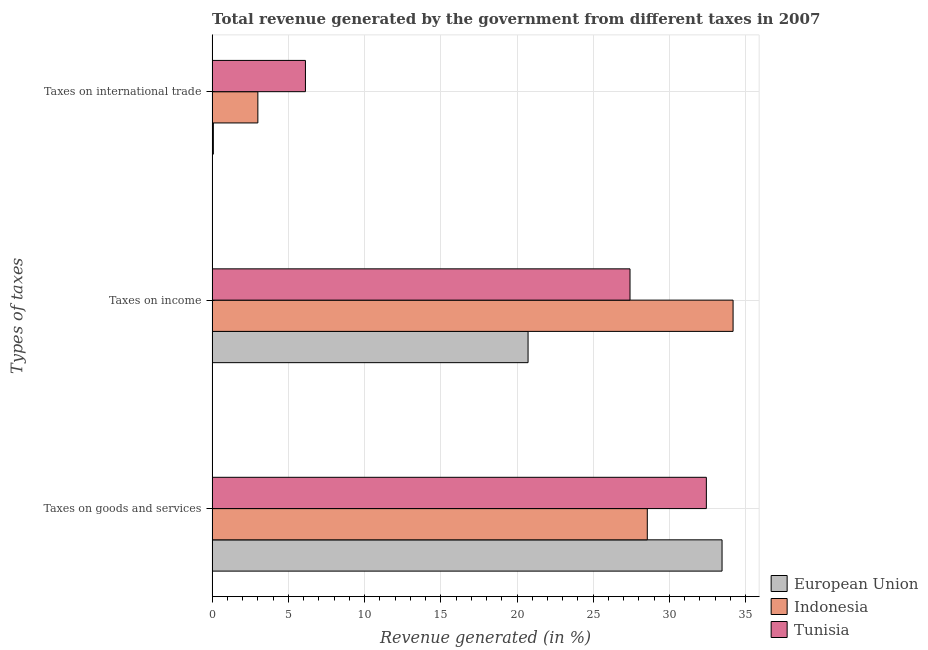How many different coloured bars are there?
Your answer should be very brief. 3. How many groups of bars are there?
Your answer should be very brief. 3. Are the number of bars per tick equal to the number of legend labels?
Give a very brief answer. Yes. How many bars are there on the 2nd tick from the top?
Your answer should be very brief. 3. How many bars are there on the 1st tick from the bottom?
Keep it short and to the point. 3. What is the label of the 2nd group of bars from the top?
Your answer should be very brief. Taxes on income. What is the percentage of revenue generated by taxes on goods and services in Tunisia?
Your response must be concise. 32.42. Across all countries, what is the maximum percentage of revenue generated by tax on international trade?
Keep it short and to the point. 6.12. Across all countries, what is the minimum percentage of revenue generated by taxes on goods and services?
Give a very brief answer. 28.55. In which country was the percentage of revenue generated by taxes on goods and services maximum?
Offer a very short reply. European Union. In which country was the percentage of revenue generated by tax on international trade minimum?
Your answer should be compact. European Union. What is the total percentage of revenue generated by taxes on goods and services in the graph?
Ensure brevity in your answer.  94.42. What is the difference between the percentage of revenue generated by taxes on income in European Union and that in Tunisia?
Your response must be concise. -6.69. What is the difference between the percentage of revenue generated by tax on international trade in European Union and the percentage of revenue generated by taxes on income in Indonesia?
Your response must be concise. -34.09. What is the average percentage of revenue generated by taxes on income per country?
Make the answer very short. 27.44. What is the difference between the percentage of revenue generated by taxes on income and percentage of revenue generated by tax on international trade in Tunisia?
Offer a terse response. 21.29. In how many countries, is the percentage of revenue generated by taxes on goods and services greater than 22 %?
Your response must be concise. 3. What is the ratio of the percentage of revenue generated by tax on international trade in Tunisia to that in European Union?
Provide a short and direct response. 75.89. What is the difference between the highest and the second highest percentage of revenue generated by tax on international trade?
Provide a short and direct response. 3.12. What is the difference between the highest and the lowest percentage of revenue generated by taxes on income?
Ensure brevity in your answer.  13.45. In how many countries, is the percentage of revenue generated by taxes on income greater than the average percentage of revenue generated by taxes on income taken over all countries?
Ensure brevity in your answer.  1. What does the 1st bar from the top in Taxes on international trade represents?
Give a very brief answer. Tunisia. Is it the case that in every country, the sum of the percentage of revenue generated by taxes on goods and services and percentage of revenue generated by taxes on income is greater than the percentage of revenue generated by tax on international trade?
Give a very brief answer. Yes. How many bars are there?
Your answer should be compact. 9. Are all the bars in the graph horizontal?
Ensure brevity in your answer.  Yes. How many countries are there in the graph?
Your response must be concise. 3. Are the values on the major ticks of X-axis written in scientific E-notation?
Keep it short and to the point. No. Does the graph contain any zero values?
Provide a succinct answer. No. Does the graph contain grids?
Give a very brief answer. Yes. Where does the legend appear in the graph?
Offer a very short reply. Bottom right. How many legend labels are there?
Your answer should be compact. 3. How are the legend labels stacked?
Your answer should be compact. Vertical. What is the title of the graph?
Your answer should be compact. Total revenue generated by the government from different taxes in 2007. Does "Barbados" appear as one of the legend labels in the graph?
Your answer should be compact. No. What is the label or title of the X-axis?
Your answer should be compact. Revenue generated (in %). What is the label or title of the Y-axis?
Ensure brevity in your answer.  Types of taxes. What is the Revenue generated (in %) of European Union in Taxes on goods and services?
Offer a terse response. 33.45. What is the Revenue generated (in %) of Indonesia in Taxes on goods and services?
Provide a succinct answer. 28.55. What is the Revenue generated (in %) of Tunisia in Taxes on goods and services?
Offer a terse response. 32.42. What is the Revenue generated (in %) of European Union in Taxes on income?
Offer a very short reply. 20.72. What is the Revenue generated (in %) in Indonesia in Taxes on income?
Provide a short and direct response. 34.17. What is the Revenue generated (in %) of Tunisia in Taxes on income?
Keep it short and to the point. 27.41. What is the Revenue generated (in %) in European Union in Taxes on international trade?
Offer a very short reply. 0.08. What is the Revenue generated (in %) in Indonesia in Taxes on international trade?
Provide a short and direct response. 3. What is the Revenue generated (in %) of Tunisia in Taxes on international trade?
Your response must be concise. 6.12. Across all Types of taxes, what is the maximum Revenue generated (in %) of European Union?
Give a very brief answer. 33.45. Across all Types of taxes, what is the maximum Revenue generated (in %) of Indonesia?
Your answer should be compact. 34.17. Across all Types of taxes, what is the maximum Revenue generated (in %) in Tunisia?
Provide a succinct answer. 32.42. Across all Types of taxes, what is the minimum Revenue generated (in %) of European Union?
Offer a very short reply. 0.08. Across all Types of taxes, what is the minimum Revenue generated (in %) in Indonesia?
Your response must be concise. 3. Across all Types of taxes, what is the minimum Revenue generated (in %) of Tunisia?
Your answer should be compact. 6.12. What is the total Revenue generated (in %) in European Union in the graph?
Your answer should be very brief. 54.26. What is the total Revenue generated (in %) of Indonesia in the graph?
Your answer should be compact. 65.72. What is the total Revenue generated (in %) of Tunisia in the graph?
Provide a short and direct response. 65.96. What is the difference between the Revenue generated (in %) in European Union in Taxes on goods and services and that in Taxes on income?
Provide a short and direct response. 12.73. What is the difference between the Revenue generated (in %) in Indonesia in Taxes on goods and services and that in Taxes on income?
Give a very brief answer. -5.63. What is the difference between the Revenue generated (in %) in Tunisia in Taxes on goods and services and that in Taxes on income?
Make the answer very short. 5.01. What is the difference between the Revenue generated (in %) of European Union in Taxes on goods and services and that in Taxes on international trade?
Offer a very short reply. 33.37. What is the difference between the Revenue generated (in %) in Indonesia in Taxes on goods and services and that in Taxes on international trade?
Your answer should be very brief. 25.55. What is the difference between the Revenue generated (in %) in Tunisia in Taxes on goods and services and that in Taxes on international trade?
Offer a terse response. 26.3. What is the difference between the Revenue generated (in %) of European Union in Taxes on income and that in Taxes on international trade?
Your answer should be very brief. 20.64. What is the difference between the Revenue generated (in %) of Indonesia in Taxes on income and that in Taxes on international trade?
Offer a very short reply. 31.17. What is the difference between the Revenue generated (in %) in Tunisia in Taxes on income and that in Taxes on international trade?
Ensure brevity in your answer.  21.29. What is the difference between the Revenue generated (in %) in European Union in Taxes on goods and services and the Revenue generated (in %) in Indonesia in Taxes on income?
Your response must be concise. -0.72. What is the difference between the Revenue generated (in %) of European Union in Taxes on goods and services and the Revenue generated (in %) of Tunisia in Taxes on income?
Make the answer very short. 6.04. What is the difference between the Revenue generated (in %) in Indonesia in Taxes on goods and services and the Revenue generated (in %) in Tunisia in Taxes on income?
Ensure brevity in your answer.  1.13. What is the difference between the Revenue generated (in %) of European Union in Taxes on goods and services and the Revenue generated (in %) of Indonesia in Taxes on international trade?
Offer a terse response. 30.45. What is the difference between the Revenue generated (in %) in European Union in Taxes on goods and services and the Revenue generated (in %) in Tunisia in Taxes on international trade?
Give a very brief answer. 27.33. What is the difference between the Revenue generated (in %) of Indonesia in Taxes on goods and services and the Revenue generated (in %) of Tunisia in Taxes on international trade?
Make the answer very short. 22.43. What is the difference between the Revenue generated (in %) in European Union in Taxes on income and the Revenue generated (in %) in Indonesia in Taxes on international trade?
Ensure brevity in your answer.  17.73. What is the difference between the Revenue generated (in %) of European Union in Taxes on income and the Revenue generated (in %) of Tunisia in Taxes on international trade?
Make the answer very short. 14.6. What is the difference between the Revenue generated (in %) of Indonesia in Taxes on income and the Revenue generated (in %) of Tunisia in Taxes on international trade?
Make the answer very short. 28.05. What is the average Revenue generated (in %) in European Union per Types of taxes?
Keep it short and to the point. 18.09. What is the average Revenue generated (in %) of Indonesia per Types of taxes?
Ensure brevity in your answer.  21.91. What is the average Revenue generated (in %) in Tunisia per Types of taxes?
Ensure brevity in your answer.  21.99. What is the difference between the Revenue generated (in %) of European Union and Revenue generated (in %) of Indonesia in Taxes on goods and services?
Give a very brief answer. 4.9. What is the difference between the Revenue generated (in %) in European Union and Revenue generated (in %) in Tunisia in Taxes on goods and services?
Make the answer very short. 1.03. What is the difference between the Revenue generated (in %) of Indonesia and Revenue generated (in %) of Tunisia in Taxes on goods and services?
Your response must be concise. -3.87. What is the difference between the Revenue generated (in %) of European Union and Revenue generated (in %) of Indonesia in Taxes on income?
Keep it short and to the point. -13.45. What is the difference between the Revenue generated (in %) of European Union and Revenue generated (in %) of Tunisia in Taxes on income?
Your response must be concise. -6.69. What is the difference between the Revenue generated (in %) of Indonesia and Revenue generated (in %) of Tunisia in Taxes on income?
Offer a very short reply. 6.76. What is the difference between the Revenue generated (in %) in European Union and Revenue generated (in %) in Indonesia in Taxes on international trade?
Your response must be concise. -2.92. What is the difference between the Revenue generated (in %) in European Union and Revenue generated (in %) in Tunisia in Taxes on international trade?
Your response must be concise. -6.04. What is the difference between the Revenue generated (in %) of Indonesia and Revenue generated (in %) of Tunisia in Taxes on international trade?
Offer a very short reply. -3.12. What is the ratio of the Revenue generated (in %) of European Union in Taxes on goods and services to that in Taxes on income?
Offer a terse response. 1.61. What is the ratio of the Revenue generated (in %) of Indonesia in Taxes on goods and services to that in Taxes on income?
Ensure brevity in your answer.  0.84. What is the ratio of the Revenue generated (in %) in Tunisia in Taxes on goods and services to that in Taxes on income?
Make the answer very short. 1.18. What is the ratio of the Revenue generated (in %) in European Union in Taxes on goods and services to that in Taxes on international trade?
Your response must be concise. 414.68. What is the ratio of the Revenue generated (in %) of Indonesia in Taxes on goods and services to that in Taxes on international trade?
Offer a very short reply. 9.52. What is the ratio of the Revenue generated (in %) of Tunisia in Taxes on goods and services to that in Taxes on international trade?
Give a very brief answer. 5.3. What is the ratio of the Revenue generated (in %) in European Union in Taxes on income to that in Taxes on international trade?
Give a very brief answer. 256.92. What is the ratio of the Revenue generated (in %) of Indonesia in Taxes on income to that in Taxes on international trade?
Ensure brevity in your answer.  11.39. What is the ratio of the Revenue generated (in %) of Tunisia in Taxes on income to that in Taxes on international trade?
Keep it short and to the point. 4.48. What is the difference between the highest and the second highest Revenue generated (in %) of European Union?
Provide a short and direct response. 12.73. What is the difference between the highest and the second highest Revenue generated (in %) in Indonesia?
Your response must be concise. 5.63. What is the difference between the highest and the second highest Revenue generated (in %) of Tunisia?
Keep it short and to the point. 5.01. What is the difference between the highest and the lowest Revenue generated (in %) of European Union?
Keep it short and to the point. 33.37. What is the difference between the highest and the lowest Revenue generated (in %) in Indonesia?
Ensure brevity in your answer.  31.17. What is the difference between the highest and the lowest Revenue generated (in %) of Tunisia?
Keep it short and to the point. 26.3. 